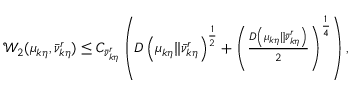<formula> <loc_0><loc_0><loc_500><loc_500>\begin{array} { r } { \mathcal { W } _ { 2 } ( \mu _ { k \eta } , \ B a r { \nu } _ { k \eta } ^ { r } ) \leq C _ { \ B a r { \nu } _ { k \eta } ^ { r } } \left ( D \left ( \mu _ { k \eta } \| \ B a r { \nu } _ { k \eta } ^ { r } \right ) ^ { \frac { 1 } { 2 } } + \left ( \frac { D \left ( \mu _ { k \eta } \| \ B a r { \nu } _ { k \eta } ^ { r } \right ) } { 2 } \right ) ^ { \frac { 1 } { 4 } } \right ) , } \end{array}</formula> 